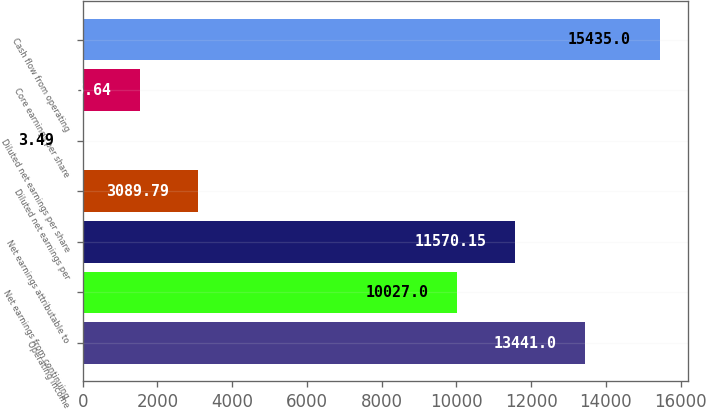<chart> <loc_0><loc_0><loc_500><loc_500><bar_chart><fcel>Operating income<fcel>Net earnings from continuing<fcel>Net earnings attributable to<fcel>Diluted net earnings per<fcel>Diluted net earnings per share<fcel>Core earnings per share<fcel>Cash flow from operating<nl><fcel>13441<fcel>10027<fcel>11570.1<fcel>3089.79<fcel>3.49<fcel>1546.64<fcel>15435<nl></chart> 